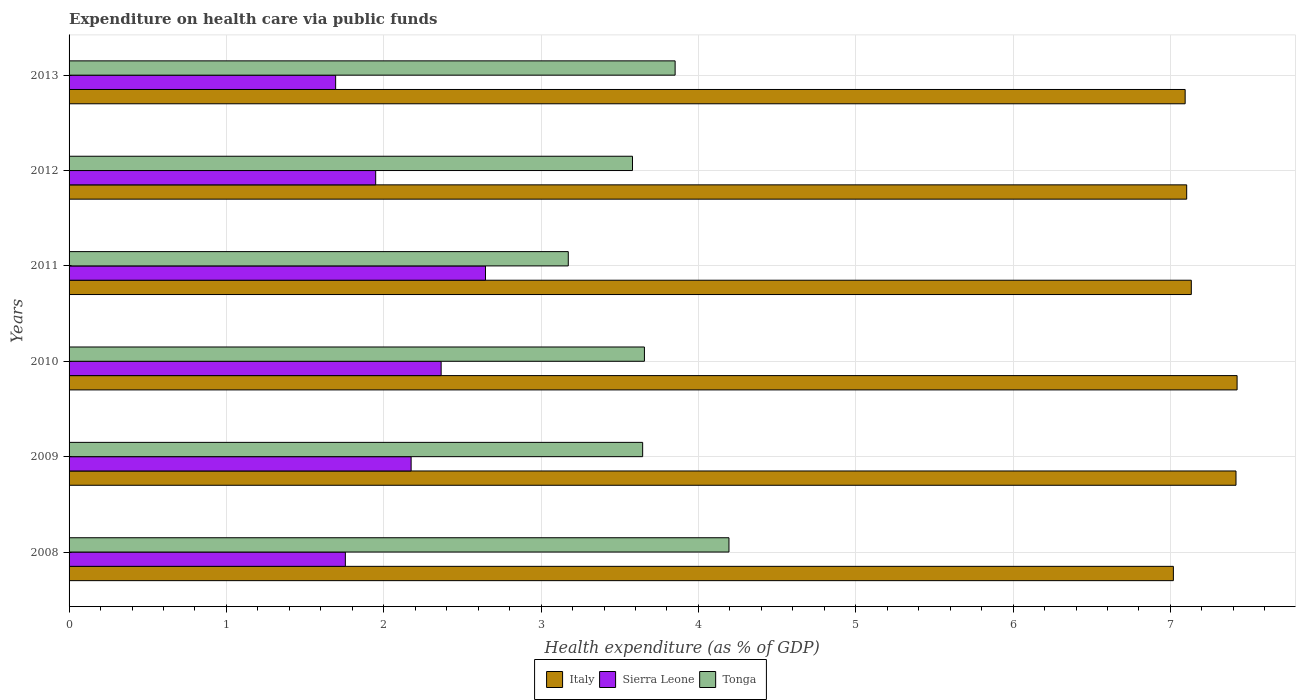How many bars are there on the 6th tick from the bottom?
Your response must be concise. 3. What is the label of the 3rd group of bars from the top?
Your answer should be compact. 2011. In how many cases, is the number of bars for a given year not equal to the number of legend labels?
Make the answer very short. 0. What is the expenditure made on health care in Italy in 2011?
Your answer should be very brief. 7.13. Across all years, what is the maximum expenditure made on health care in Tonga?
Your response must be concise. 4.19. Across all years, what is the minimum expenditure made on health care in Italy?
Keep it short and to the point. 7.02. What is the total expenditure made on health care in Tonga in the graph?
Your response must be concise. 22.1. What is the difference between the expenditure made on health care in Tonga in 2008 and that in 2013?
Make the answer very short. 0.34. What is the difference between the expenditure made on health care in Tonga in 2010 and the expenditure made on health care in Italy in 2011?
Provide a short and direct response. -3.48. What is the average expenditure made on health care in Italy per year?
Ensure brevity in your answer.  7.2. In the year 2012, what is the difference between the expenditure made on health care in Tonga and expenditure made on health care in Italy?
Your answer should be very brief. -3.52. What is the ratio of the expenditure made on health care in Italy in 2008 to that in 2010?
Ensure brevity in your answer.  0.95. Is the expenditure made on health care in Italy in 2010 less than that in 2012?
Ensure brevity in your answer.  No. What is the difference between the highest and the second highest expenditure made on health care in Tonga?
Offer a very short reply. 0.34. What is the difference between the highest and the lowest expenditure made on health care in Sierra Leone?
Provide a short and direct response. 0.95. In how many years, is the expenditure made on health care in Italy greater than the average expenditure made on health care in Italy taken over all years?
Keep it short and to the point. 2. Is the sum of the expenditure made on health care in Sierra Leone in 2011 and 2013 greater than the maximum expenditure made on health care in Italy across all years?
Offer a terse response. No. What does the 2nd bar from the top in 2011 represents?
Ensure brevity in your answer.  Sierra Leone. What does the 3rd bar from the bottom in 2013 represents?
Provide a short and direct response. Tonga. Is it the case that in every year, the sum of the expenditure made on health care in Sierra Leone and expenditure made on health care in Italy is greater than the expenditure made on health care in Tonga?
Keep it short and to the point. Yes. Are all the bars in the graph horizontal?
Provide a short and direct response. Yes. How many years are there in the graph?
Offer a terse response. 6. Are the values on the major ticks of X-axis written in scientific E-notation?
Ensure brevity in your answer.  No. Does the graph contain any zero values?
Your answer should be compact. No. Does the graph contain grids?
Offer a terse response. Yes. Where does the legend appear in the graph?
Offer a very short reply. Bottom center. How are the legend labels stacked?
Your answer should be compact. Horizontal. What is the title of the graph?
Provide a short and direct response. Expenditure on health care via public funds. What is the label or title of the X-axis?
Offer a very short reply. Health expenditure (as % of GDP). What is the Health expenditure (as % of GDP) in Italy in 2008?
Your answer should be very brief. 7.02. What is the Health expenditure (as % of GDP) of Sierra Leone in 2008?
Provide a short and direct response. 1.76. What is the Health expenditure (as % of GDP) in Tonga in 2008?
Give a very brief answer. 4.19. What is the Health expenditure (as % of GDP) of Italy in 2009?
Offer a terse response. 7.42. What is the Health expenditure (as % of GDP) in Sierra Leone in 2009?
Offer a very short reply. 2.17. What is the Health expenditure (as % of GDP) of Tonga in 2009?
Your response must be concise. 3.65. What is the Health expenditure (as % of GDP) in Italy in 2010?
Your answer should be compact. 7.42. What is the Health expenditure (as % of GDP) of Sierra Leone in 2010?
Give a very brief answer. 2.36. What is the Health expenditure (as % of GDP) of Tonga in 2010?
Your answer should be very brief. 3.66. What is the Health expenditure (as % of GDP) of Italy in 2011?
Your answer should be very brief. 7.13. What is the Health expenditure (as % of GDP) of Sierra Leone in 2011?
Offer a very short reply. 2.65. What is the Health expenditure (as % of GDP) of Tonga in 2011?
Offer a terse response. 3.17. What is the Health expenditure (as % of GDP) in Italy in 2012?
Your answer should be very brief. 7.1. What is the Health expenditure (as % of GDP) of Sierra Leone in 2012?
Give a very brief answer. 1.95. What is the Health expenditure (as % of GDP) of Tonga in 2012?
Your answer should be compact. 3.58. What is the Health expenditure (as % of GDP) of Italy in 2013?
Offer a very short reply. 7.09. What is the Health expenditure (as % of GDP) in Sierra Leone in 2013?
Offer a terse response. 1.69. What is the Health expenditure (as % of GDP) in Tonga in 2013?
Give a very brief answer. 3.85. Across all years, what is the maximum Health expenditure (as % of GDP) of Italy?
Your answer should be very brief. 7.42. Across all years, what is the maximum Health expenditure (as % of GDP) of Sierra Leone?
Make the answer very short. 2.65. Across all years, what is the maximum Health expenditure (as % of GDP) of Tonga?
Offer a very short reply. 4.19. Across all years, what is the minimum Health expenditure (as % of GDP) of Italy?
Make the answer very short. 7.02. Across all years, what is the minimum Health expenditure (as % of GDP) of Sierra Leone?
Provide a short and direct response. 1.69. Across all years, what is the minimum Health expenditure (as % of GDP) of Tonga?
Keep it short and to the point. 3.17. What is the total Health expenditure (as % of GDP) in Italy in the graph?
Make the answer very short. 43.19. What is the total Health expenditure (as % of GDP) in Sierra Leone in the graph?
Provide a succinct answer. 12.58. What is the total Health expenditure (as % of GDP) of Tonga in the graph?
Your answer should be compact. 22.1. What is the difference between the Health expenditure (as % of GDP) in Italy in 2008 and that in 2009?
Keep it short and to the point. -0.4. What is the difference between the Health expenditure (as % of GDP) of Sierra Leone in 2008 and that in 2009?
Offer a very short reply. -0.42. What is the difference between the Health expenditure (as % of GDP) in Tonga in 2008 and that in 2009?
Your answer should be compact. 0.55. What is the difference between the Health expenditure (as % of GDP) of Italy in 2008 and that in 2010?
Ensure brevity in your answer.  -0.41. What is the difference between the Health expenditure (as % of GDP) of Sierra Leone in 2008 and that in 2010?
Provide a short and direct response. -0.61. What is the difference between the Health expenditure (as % of GDP) in Tonga in 2008 and that in 2010?
Offer a very short reply. 0.54. What is the difference between the Health expenditure (as % of GDP) in Italy in 2008 and that in 2011?
Make the answer very short. -0.11. What is the difference between the Health expenditure (as % of GDP) in Sierra Leone in 2008 and that in 2011?
Provide a succinct answer. -0.89. What is the difference between the Health expenditure (as % of GDP) of Tonga in 2008 and that in 2011?
Provide a succinct answer. 1.02. What is the difference between the Health expenditure (as % of GDP) of Italy in 2008 and that in 2012?
Give a very brief answer. -0.08. What is the difference between the Health expenditure (as % of GDP) of Sierra Leone in 2008 and that in 2012?
Provide a succinct answer. -0.19. What is the difference between the Health expenditure (as % of GDP) of Tonga in 2008 and that in 2012?
Your response must be concise. 0.61. What is the difference between the Health expenditure (as % of GDP) of Italy in 2008 and that in 2013?
Your answer should be compact. -0.07. What is the difference between the Health expenditure (as % of GDP) in Sierra Leone in 2008 and that in 2013?
Give a very brief answer. 0.06. What is the difference between the Health expenditure (as % of GDP) of Tonga in 2008 and that in 2013?
Make the answer very short. 0.34. What is the difference between the Health expenditure (as % of GDP) in Italy in 2009 and that in 2010?
Provide a short and direct response. -0.01. What is the difference between the Health expenditure (as % of GDP) of Sierra Leone in 2009 and that in 2010?
Keep it short and to the point. -0.19. What is the difference between the Health expenditure (as % of GDP) of Tonga in 2009 and that in 2010?
Give a very brief answer. -0.01. What is the difference between the Health expenditure (as % of GDP) of Italy in 2009 and that in 2011?
Provide a short and direct response. 0.28. What is the difference between the Health expenditure (as % of GDP) in Sierra Leone in 2009 and that in 2011?
Offer a very short reply. -0.47. What is the difference between the Health expenditure (as % of GDP) of Tonga in 2009 and that in 2011?
Your answer should be compact. 0.47. What is the difference between the Health expenditure (as % of GDP) in Italy in 2009 and that in 2012?
Your answer should be very brief. 0.31. What is the difference between the Health expenditure (as % of GDP) in Sierra Leone in 2009 and that in 2012?
Your response must be concise. 0.23. What is the difference between the Health expenditure (as % of GDP) of Tonga in 2009 and that in 2012?
Offer a terse response. 0.06. What is the difference between the Health expenditure (as % of GDP) of Italy in 2009 and that in 2013?
Ensure brevity in your answer.  0.32. What is the difference between the Health expenditure (as % of GDP) of Sierra Leone in 2009 and that in 2013?
Make the answer very short. 0.48. What is the difference between the Health expenditure (as % of GDP) of Tonga in 2009 and that in 2013?
Provide a succinct answer. -0.21. What is the difference between the Health expenditure (as % of GDP) in Italy in 2010 and that in 2011?
Your answer should be compact. 0.29. What is the difference between the Health expenditure (as % of GDP) in Sierra Leone in 2010 and that in 2011?
Your answer should be compact. -0.28. What is the difference between the Health expenditure (as % of GDP) of Tonga in 2010 and that in 2011?
Keep it short and to the point. 0.48. What is the difference between the Health expenditure (as % of GDP) of Italy in 2010 and that in 2012?
Your answer should be compact. 0.32. What is the difference between the Health expenditure (as % of GDP) in Sierra Leone in 2010 and that in 2012?
Give a very brief answer. 0.42. What is the difference between the Health expenditure (as % of GDP) in Tonga in 2010 and that in 2012?
Provide a succinct answer. 0.08. What is the difference between the Health expenditure (as % of GDP) of Italy in 2010 and that in 2013?
Provide a short and direct response. 0.33. What is the difference between the Health expenditure (as % of GDP) in Sierra Leone in 2010 and that in 2013?
Give a very brief answer. 0.67. What is the difference between the Health expenditure (as % of GDP) in Tonga in 2010 and that in 2013?
Ensure brevity in your answer.  -0.2. What is the difference between the Health expenditure (as % of GDP) of Italy in 2011 and that in 2012?
Make the answer very short. 0.03. What is the difference between the Health expenditure (as % of GDP) in Sierra Leone in 2011 and that in 2012?
Ensure brevity in your answer.  0.7. What is the difference between the Health expenditure (as % of GDP) of Tonga in 2011 and that in 2012?
Your answer should be compact. -0.41. What is the difference between the Health expenditure (as % of GDP) in Italy in 2011 and that in 2013?
Offer a terse response. 0.04. What is the difference between the Health expenditure (as % of GDP) of Sierra Leone in 2011 and that in 2013?
Ensure brevity in your answer.  0.95. What is the difference between the Health expenditure (as % of GDP) of Tonga in 2011 and that in 2013?
Ensure brevity in your answer.  -0.68. What is the difference between the Health expenditure (as % of GDP) in Italy in 2012 and that in 2013?
Give a very brief answer. 0.01. What is the difference between the Health expenditure (as % of GDP) in Sierra Leone in 2012 and that in 2013?
Ensure brevity in your answer.  0.25. What is the difference between the Health expenditure (as % of GDP) in Tonga in 2012 and that in 2013?
Provide a succinct answer. -0.27. What is the difference between the Health expenditure (as % of GDP) of Italy in 2008 and the Health expenditure (as % of GDP) of Sierra Leone in 2009?
Ensure brevity in your answer.  4.84. What is the difference between the Health expenditure (as % of GDP) of Italy in 2008 and the Health expenditure (as % of GDP) of Tonga in 2009?
Your response must be concise. 3.37. What is the difference between the Health expenditure (as % of GDP) in Sierra Leone in 2008 and the Health expenditure (as % of GDP) in Tonga in 2009?
Make the answer very short. -1.89. What is the difference between the Health expenditure (as % of GDP) of Italy in 2008 and the Health expenditure (as % of GDP) of Sierra Leone in 2010?
Make the answer very short. 4.65. What is the difference between the Health expenditure (as % of GDP) in Italy in 2008 and the Health expenditure (as % of GDP) in Tonga in 2010?
Ensure brevity in your answer.  3.36. What is the difference between the Health expenditure (as % of GDP) of Sierra Leone in 2008 and the Health expenditure (as % of GDP) of Tonga in 2010?
Give a very brief answer. -1.9. What is the difference between the Health expenditure (as % of GDP) of Italy in 2008 and the Health expenditure (as % of GDP) of Sierra Leone in 2011?
Provide a short and direct response. 4.37. What is the difference between the Health expenditure (as % of GDP) of Italy in 2008 and the Health expenditure (as % of GDP) of Tonga in 2011?
Make the answer very short. 3.85. What is the difference between the Health expenditure (as % of GDP) in Sierra Leone in 2008 and the Health expenditure (as % of GDP) in Tonga in 2011?
Provide a succinct answer. -1.42. What is the difference between the Health expenditure (as % of GDP) in Italy in 2008 and the Health expenditure (as % of GDP) in Sierra Leone in 2012?
Your answer should be compact. 5.07. What is the difference between the Health expenditure (as % of GDP) of Italy in 2008 and the Health expenditure (as % of GDP) of Tonga in 2012?
Keep it short and to the point. 3.44. What is the difference between the Health expenditure (as % of GDP) of Sierra Leone in 2008 and the Health expenditure (as % of GDP) of Tonga in 2012?
Make the answer very short. -1.83. What is the difference between the Health expenditure (as % of GDP) of Italy in 2008 and the Health expenditure (as % of GDP) of Sierra Leone in 2013?
Keep it short and to the point. 5.32. What is the difference between the Health expenditure (as % of GDP) of Italy in 2008 and the Health expenditure (as % of GDP) of Tonga in 2013?
Offer a terse response. 3.17. What is the difference between the Health expenditure (as % of GDP) of Sierra Leone in 2008 and the Health expenditure (as % of GDP) of Tonga in 2013?
Keep it short and to the point. -2.1. What is the difference between the Health expenditure (as % of GDP) of Italy in 2009 and the Health expenditure (as % of GDP) of Sierra Leone in 2010?
Offer a very short reply. 5.05. What is the difference between the Health expenditure (as % of GDP) in Italy in 2009 and the Health expenditure (as % of GDP) in Tonga in 2010?
Give a very brief answer. 3.76. What is the difference between the Health expenditure (as % of GDP) of Sierra Leone in 2009 and the Health expenditure (as % of GDP) of Tonga in 2010?
Ensure brevity in your answer.  -1.48. What is the difference between the Health expenditure (as % of GDP) of Italy in 2009 and the Health expenditure (as % of GDP) of Sierra Leone in 2011?
Offer a very short reply. 4.77. What is the difference between the Health expenditure (as % of GDP) in Italy in 2009 and the Health expenditure (as % of GDP) in Tonga in 2011?
Your response must be concise. 4.24. What is the difference between the Health expenditure (as % of GDP) in Sierra Leone in 2009 and the Health expenditure (as % of GDP) in Tonga in 2011?
Your response must be concise. -1. What is the difference between the Health expenditure (as % of GDP) of Italy in 2009 and the Health expenditure (as % of GDP) of Sierra Leone in 2012?
Keep it short and to the point. 5.47. What is the difference between the Health expenditure (as % of GDP) in Italy in 2009 and the Health expenditure (as % of GDP) in Tonga in 2012?
Ensure brevity in your answer.  3.84. What is the difference between the Health expenditure (as % of GDP) of Sierra Leone in 2009 and the Health expenditure (as % of GDP) of Tonga in 2012?
Offer a very short reply. -1.41. What is the difference between the Health expenditure (as % of GDP) in Italy in 2009 and the Health expenditure (as % of GDP) in Sierra Leone in 2013?
Your answer should be compact. 5.72. What is the difference between the Health expenditure (as % of GDP) in Italy in 2009 and the Health expenditure (as % of GDP) in Tonga in 2013?
Keep it short and to the point. 3.56. What is the difference between the Health expenditure (as % of GDP) of Sierra Leone in 2009 and the Health expenditure (as % of GDP) of Tonga in 2013?
Provide a short and direct response. -1.68. What is the difference between the Health expenditure (as % of GDP) of Italy in 2010 and the Health expenditure (as % of GDP) of Sierra Leone in 2011?
Ensure brevity in your answer.  4.78. What is the difference between the Health expenditure (as % of GDP) in Italy in 2010 and the Health expenditure (as % of GDP) in Tonga in 2011?
Give a very brief answer. 4.25. What is the difference between the Health expenditure (as % of GDP) in Sierra Leone in 2010 and the Health expenditure (as % of GDP) in Tonga in 2011?
Make the answer very short. -0.81. What is the difference between the Health expenditure (as % of GDP) in Italy in 2010 and the Health expenditure (as % of GDP) in Sierra Leone in 2012?
Give a very brief answer. 5.47. What is the difference between the Health expenditure (as % of GDP) of Italy in 2010 and the Health expenditure (as % of GDP) of Tonga in 2012?
Provide a succinct answer. 3.84. What is the difference between the Health expenditure (as % of GDP) of Sierra Leone in 2010 and the Health expenditure (as % of GDP) of Tonga in 2012?
Make the answer very short. -1.22. What is the difference between the Health expenditure (as % of GDP) in Italy in 2010 and the Health expenditure (as % of GDP) in Sierra Leone in 2013?
Offer a terse response. 5.73. What is the difference between the Health expenditure (as % of GDP) of Italy in 2010 and the Health expenditure (as % of GDP) of Tonga in 2013?
Give a very brief answer. 3.57. What is the difference between the Health expenditure (as % of GDP) in Sierra Leone in 2010 and the Health expenditure (as % of GDP) in Tonga in 2013?
Make the answer very short. -1.49. What is the difference between the Health expenditure (as % of GDP) in Italy in 2011 and the Health expenditure (as % of GDP) in Sierra Leone in 2012?
Keep it short and to the point. 5.18. What is the difference between the Health expenditure (as % of GDP) in Italy in 2011 and the Health expenditure (as % of GDP) in Tonga in 2012?
Make the answer very short. 3.55. What is the difference between the Health expenditure (as % of GDP) in Sierra Leone in 2011 and the Health expenditure (as % of GDP) in Tonga in 2012?
Keep it short and to the point. -0.93. What is the difference between the Health expenditure (as % of GDP) in Italy in 2011 and the Health expenditure (as % of GDP) in Sierra Leone in 2013?
Ensure brevity in your answer.  5.44. What is the difference between the Health expenditure (as % of GDP) in Italy in 2011 and the Health expenditure (as % of GDP) in Tonga in 2013?
Your response must be concise. 3.28. What is the difference between the Health expenditure (as % of GDP) of Sierra Leone in 2011 and the Health expenditure (as % of GDP) of Tonga in 2013?
Give a very brief answer. -1.21. What is the difference between the Health expenditure (as % of GDP) of Italy in 2012 and the Health expenditure (as % of GDP) of Sierra Leone in 2013?
Keep it short and to the point. 5.41. What is the difference between the Health expenditure (as % of GDP) in Italy in 2012 and the Health expenditure (as % of GDP) in Tonga in 2013?
Provide a succinct answer. 3.25. What is the difference between the Health expenditure (as % of GDP) in Sierra Leone in 2012 and the Health expenditure (as % of GDP) in Tonga in 2013?
Provide a short and direct response. -1.9. What is the average Health expenditure (as % of GDP) of Italy per year?
Your answer should be compact. 7.2. What is the average Health expenditure (as % of GDP) of Sierra Leone per year?
Your answer should be very brief. 2.1. What is the average Health expenditure (as % of GDP) of Tonga per year?
Your response must be concise. 3.68. In the year 2008, what is the difference between the Health expenditure (as % of GDP) of Italy and Health expenditure (as % of GDP) of Sierra Leone?
Give a very brief answer. 5.26. In the year 2008, what is the difference between the Health expenditure (as % of GDP) of Italy and Health expenditure (as % of GDP) of Tonga?
Make the answer very short. 2.82. In the year 2008, what is the difference between the Health expenditure (as % of GDP) of Sierra Leone and Health expenditure (as % of GDP) of Tonga?
Your answer should be compact. -2.44. In the year 2009, what is the difference between the Health expenditure (as % of GDP) in Italy and Health expenditure (as % of GDP) in Sierra Leone?
Give a very brief answer. 5.24. In the year 2009, what is the difference between the Health expenditure (as % of GDP) in Italy and Health expenditure (as % of GDP) in Tonga?
Offer a terse response. 3.77. In the year 2009, what is the difference between the Health expenditure (as % of GDP) in Sierra Leone and Health expenditure (as % of GDP) in Tonga?
Your response must be concise. -1.47. In the year 2010, what is the difference between the Health expenditure (as % of GDP) of Italy and Health expenditure (as % of GDP) of Sierra Leone?
Your answer should be very brief. 5.06. In the year 2010, what is the difference between the Health expenditure (as % of GDP) in Italy and Health expenditure (as % of GDP) in Tonga?
Ensure brevity in your answer.  3.77. In the year 2010, what is the difference between the Health expenditure (as % of GDP) of Sierra Leone and Health expenditure (as % of GDP) of Tonga?
Provide a succinct answer. -1.29. In the year 2011, what is the difference between the Health expenditure (as % of GDP) in Italy and Health expenditure (as % of GDP) in Sierra Leone?
Ensure brevity in your answer.  4.49. In the year 2011, what is the difference between the Health expenditure (as % of GDP) of Italy and Health expenditure (as % of GDP) of Tonga?
Provide a succinct answer. 3.96. In the year 2011, what is the difference between the Health expenditure (as % of GDP) of Sierra Leone and Health expenditure (as % of GDP) of Tonga?
Your answer should be compact. -0.53. In the year 2012, what is the difference between the Health expenditure (as % of GDP) in Italy and Health expenditure (as % of GDP) in Sierra Leone?
Ensure brevity in your answer.  5.15. In the year 2012, what is the difference between the Health expenditure (as % of GDP) of Italy and Health expenditure (as % of GDP) of Tonga?
Your answer should be compact. 3.52. In the year 2012, what is the difference between the Health expenditure (as % of GDP) in Sierra Leone and Health expenditure (as % of GDP) in Tonga?
Give a very brief answer. -1.63. In the year 2013, what is the difference between the Health expenditure (as % of GDP) in Italy and Health expenditure (as % of GDP) in Sierra Leone?
Make the answer very short. 5.4. In the year 2013, what is the difference between the Health expenditure (as % of GDP) in Italy and Health expenditure (as % of GDP) in Tonga?
Your answer should be compact. 3.24. In the year 2013, what is the difference between the Health expenditure (as % of GDP) of Sierra Leone and Health expenditure (as % of GDP) of Tonga?
Give a very brief answer. -2.16. What is the ratio of the Health expenditure (as % of GDP) in Italy in 2008 to that in 2009?
Your answer should be very brief. 0.95. What is the ratio of the Health expenditure (as % of GDP) in Sierra Leone in 2008 to that in 2009?
Provide a short and direct response. 0.81. What is the ratio of the Health expenditure (as % of GDP) in Tonga in 2008 to that in 2009?
Your answer should be compact. 1.15. What is the ratio of the Health expenditure (as % of GDP) in Italy in 2008 to that in 2010?
Ensure brevity in your answer.  0.95. What is the ratio of the Health expenditure (as % of GDP) of Sierra Leone in 2008 to that in 2010?
Offer a terse response. 0.74. What is the ratio of the Health expenditure (as % of GDP) of Tonga in 2008 to that in 2010?
Offer a very short reply. 1.15. What is the ratio of the Health expenditure (as % of GDP) in Sierra Leone in 2008 to that in 2011?
Make the answer very short. 0.66. What is the ratio of the Health expenditure (as % of GDP) of Tonga in 2008 to that in 2011?
Make the answer very short. 1.32. What is the ratio of the Health expenditure (as % of GDP) of Sierra Leone in 2008 to that in 2012?
Offer a terse response. 0.9. What is the ratio of the Health expenditure (as % of GDP) in Tonga in 2008 to that in 2012?
Offer a terse response. 1.17. What is the ratio of the Health expenditure (as % of GDP) in Italy in 2008 to that in 2013?
Make the answer very short. 0.99. What is the ratio of the Health expenditure (as % of GDP) in Sierra Leone in 2008 to that in 2013?
Keep it short and to the point. 1.04. What is the ratio of the Health expenditure (as % of GDP) in Tonga in 2008 to that in 2013?
Provide a short and direct response. 1.09. What is the ratio of the Health expenditure (as % of GDP) of Italy in 2009 to that in 2010?
Offer a very short reply. 1. What is the ratio of the Health expenditure (as % of GDP) of Sierra Leone in 2009 to that in 2010?
Provide a short and direct response. 0.92. What is the ratio of the Health expenditure (as % of GDP) of Tonga in 2009 to that in 2010?
Your response must be concise. 1. What is the ratio of the Health expenditure (as % of GDP) in Italy in 2009 to that in 2011?
Give a very brief answer. 1.04. What is the ratio of the Health expenditure (as % of GDP) of Sierra Leone in 2009 to that in 2011?
Give a very brief answer. 0.82. What is the ratio of the Health expenditure (as % of GDP) of Tonga in 2009 to that in 2011?
Make the answer very short. 1.15. What is the ratio of the Health expenditure (as % of GDP) in Italy in 2009 to that in 2012?
Your response must be concise. 1.04. What is the ratio of the Health expenditure (as % of GDP) in Sierra Leone in 2009 to that in 2012?
Provide a short and direct response. 1.12. What is the ratio of the Health expenditure (as % of GDP) of Tonga in 2009 to that in 2012?
Your response must be concise. 1.02. What is the ratio of the Health expenditure (as % of GDP) in Italy in 2009 to that in 2013?
Your answer should be very brief. 1.05. What is the ratio of the Health expenditure (as % of GDP) in Sierra Leone in 2009 to that in 2013?
Ensure brevity in your answer.  1.28. What is the ratio of the Health expenditure (as % of GDP) of Tonga in 2009 to that in 2013?
Provide a short and direct response. 0.95. What is the ratio of the Health expenditure (as % of GDP) in Italy in 2010 to that in 2011?
Offer a terse response. 1.04. What is the ratio of the Health expenditure (as % of GDP) of Sierra Leone in 2010 to that in 2011?
Offer a very short reply. 0.89. What is the ratio of the Health expenditure (as % of GDP) of Tonga in 2010 to that in 2011?
Your answer should be very brief. 1.15. What is the ratio of the Health expenditure (as % of GDP) of Italy in 2010 to that in 2012?
Provide a succinct answer. 1.05. What is the ratio of the Health expenditure (as % of GDP) in Sierra Leone in 2010 to that in 2012?
Ensure brevity in your answer.  1.21. What is the ratio of the Health expenditure (as % of GDP) in Tonga in 2010 to that in 2012?
Provide a succinct answer. 1.02. What is the ratio of the Health expenditure (as % of GDP) in Italy in 2010 to that in 2013?
Provide a succinct answer. 1.05. What is the ratio of the Health expenditure (as % of GDP) of Sierra Leone in 2010 to that in 2013?
Provide a succinct answer. 1.4. What is the ratio of the Health expenditure (as % of GDP) of Tonga in 2010 to that in 2013?
Your answer should be compact. 0.95. What is the ratio of the Health expenditure (as % of GDP) in Italy in 2011 to that in 2012?
Your answer should be very brief. 1. What is the ratio of the Health expenditure (as % of GDP) in Sierra Leone in 2011 to that in 2012?
Your answer should be compact. 1.36. What is the ratio of the Health expenditure (as % of GDP) in Tonga in 2011 to that in 2012?
Your response must be concise. 0.89. What is the ratio of the Health expenditure (as % of GDP) in Sierra Leone in 2011 to that in 2013?
Your answer should be very brief. 1.56. What is the ratio of the Health expenditure (as % of GDP) of Tonga in 2011 to that in 2013?
Your answer should be compact. 0.82. What is the ratio of the Health expenditure (as % of GDP) in Italy in 2012 to that in 2013?
Your answer should be compact. 1. What is the ratio of the Health expenditure (as % of GDP) of Sierra Leone in 2012 to that in 2013?
Your answer should be compact. 1.15. What is the ratio of the Health expenditure (as % of GDP) of Tonga in 2012 to that in 2013?
Offer a terse response. 0.93. What is the difference between the highest and the second highest Health expenditure (as % of GDP) of Italy?
Provide a short and direct response. 0.01. What is the difference between the highest and the second highest Health expenditure (as % of GDP) in Sierra Leone?
Offer a very short reply. 0.28. What is the difference between the highest and the second highest Health expenditure (as % of GDP) in Tonga?
Provide a short and direct response. 0.34. What is the difference between the highest and the lowest Health expenditure (as % of GDP) in Italy?
Your answer should be very brief. 0.41. What is the difference between the highest and the lowest Health expenditure (as % of GDP) in Sierra Leone?
Ensure brevity in your answer.  0.95. What is the difference between the highest and the lowest Health expenditure (as % of GDP) in Tonga?
Offer a very short reply. 1.02. 